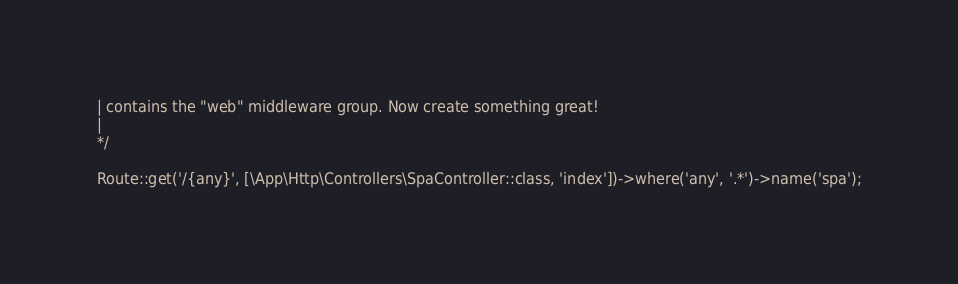Convert code to text. <code><loc_0><loc_0><loc_500><loc_500><_PHP_>| contains the "web" middleware group. Now create something great!
|
*/

Route::get('/{any}', [\App\Http\Controllers\SpaController::class, 'index'])->where('any', '.*')->name('spa');</code> 